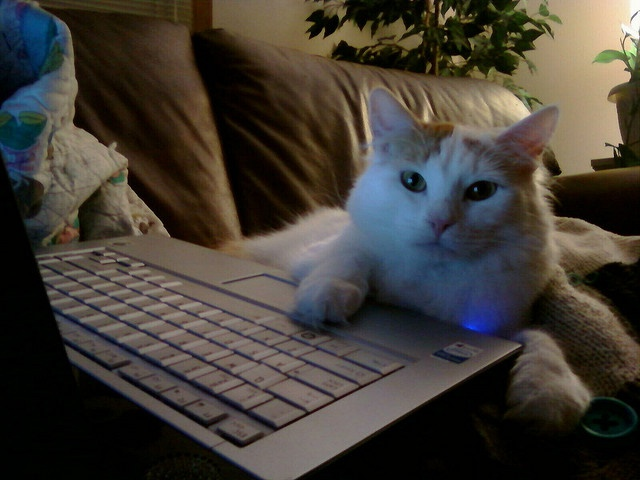Describe the objects in this image and their specific colors. I can see couch in navy, black, gray, and maroon tones, laptop in navy, gray, and black tones, cat in navy, black, and gray tones, potted plant in navy, black, olive, and tan tones, and potted plant in navy, black, ivory, and darkgreen tones in this image. 